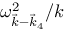Convert formula to latex. <formula><loc_0><loc_0><loc_500><loc_500>\omega _ { \vec { k } - \vec { k } _ { 4 } } ^ { 2 } / k</formula> 